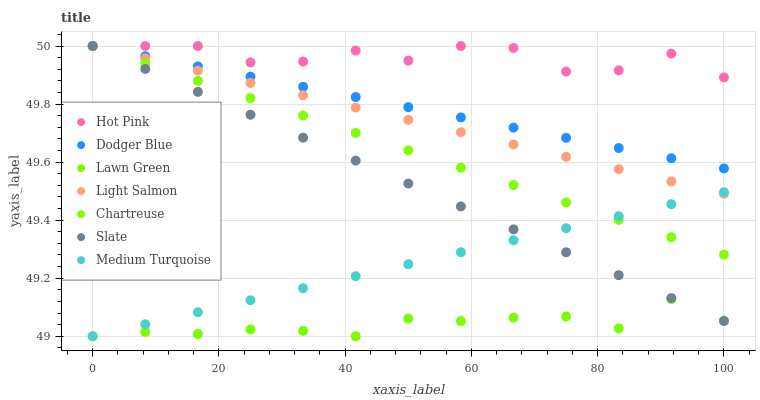Does Lawn Green have the minimum area under the curve?
Answer yes or no. Yes. Does Hot Pink have the maximum area under the curve?
Answer yes or no. Yes. Does Light Salmon have the minimum area under the curve?
Answer yes or no. No. Does Light Salmon have the maximum area under the curve?
Answer yes or no. No. Is Chartreuse the smoothest?
Answer yes or no. Yes. Is Hot Pink the roughest?
Answer yes or no. Yes. Is Light Salmon the smoothest?
Answer yes or no. No. Is Light Salmon the roughest?
Answer yes or no. No. Does Lawn Green have the lowest value?
Answer yes or no. Yes. Does Light Salmon have the lowest value?
Answer yes or no. No. Does Dodger Blue have the highest value?
Answer yes or no. Yes. Does Medium Turquoise have the highest value?
Answer yes or no. No. Is Lawn Green less than Hot Pink?
Answer yes or no. Yes. Is Hot Pink greater than Lawn Green?
Answer yes or no. Yes. Does Medium Turquoise intersect Chartreuse?
Answer yes or no. Yes. Is Medium Turquoise less than Chartreuse?
Answer yes or no. No. Is Medium Turquoise greater than Chartreuse?
Answer yes or no. No. Does Lawn Green intersect Hot Pink?
Answer yes or no. No. 